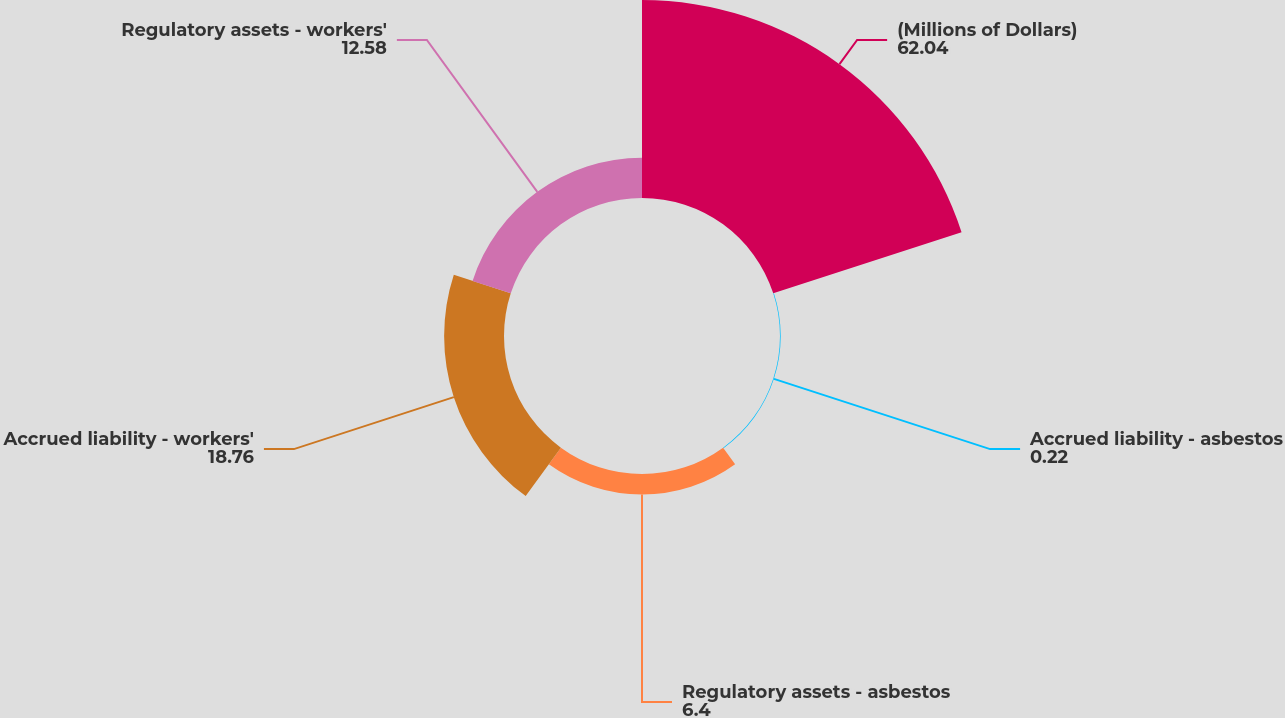Convert chart to OTSL. <chart><loc_0><loc_0><loc_500><loc_500><pie_chart><fcel>(Millions of Dollars)<fcel>Accrued liability - asbestos<fcel>Regulatory assets - asbestos<fcel>Accrued liability - workers'<fcel>Regulatory assets - workers'<nl><fcel>62.04%<fcel>0.22%<fcel>6.4%<fcel>18.76%<fcel>12.58%<nl></chart> 